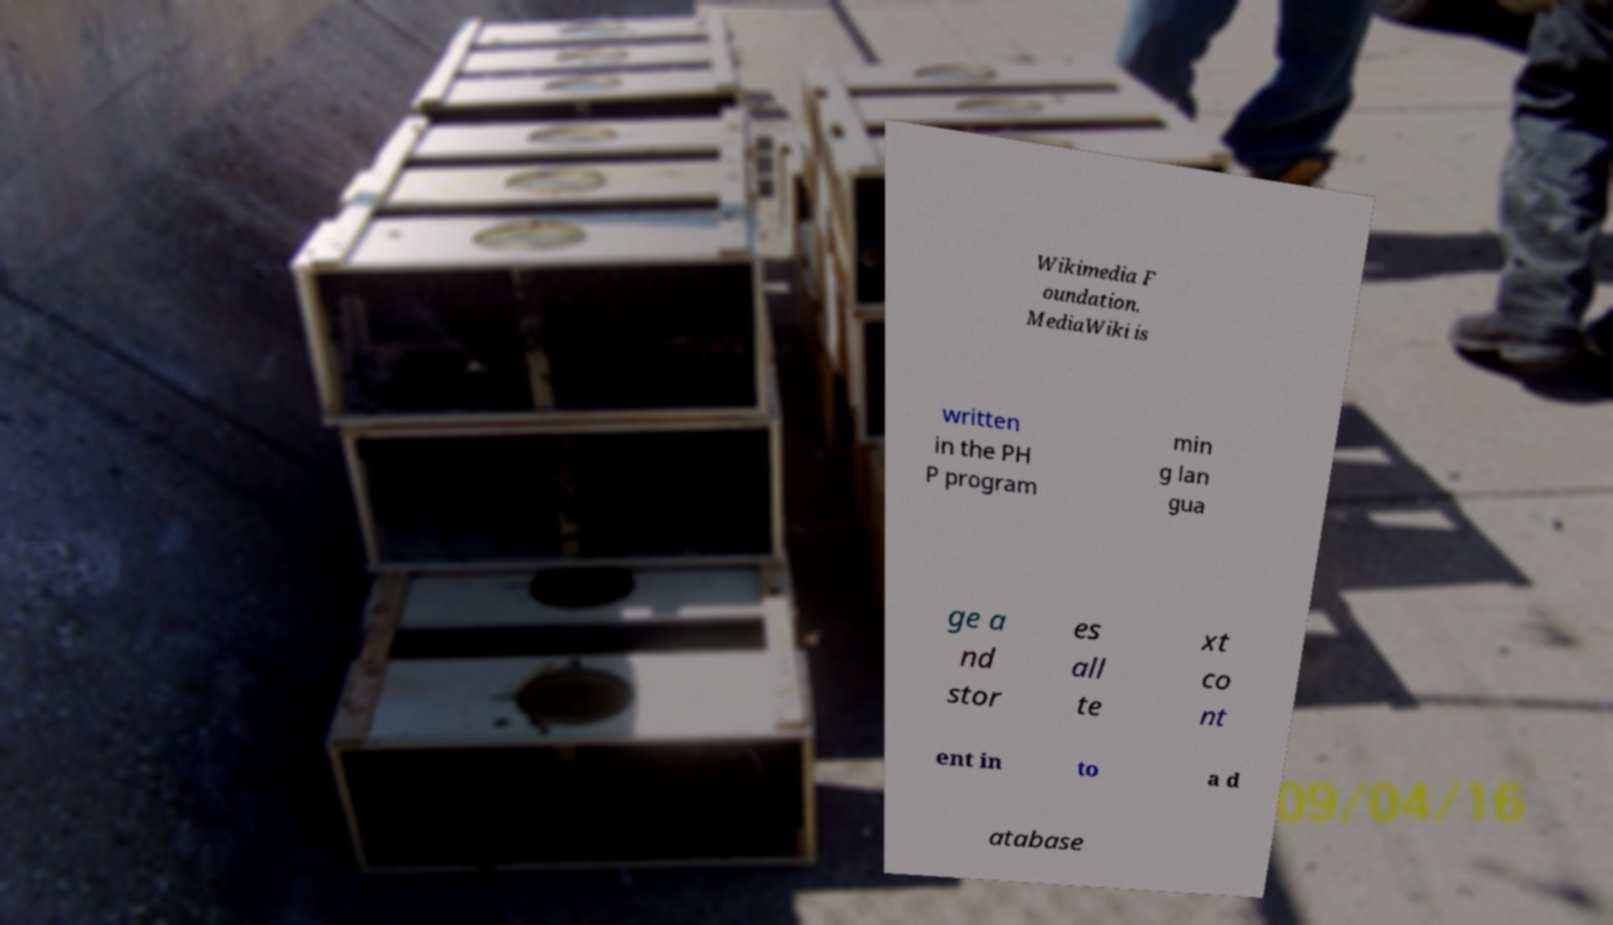Can you read and provide the text displayed in the image?This photo seems to have some interesting text. Can you extract and type it out for me? Wikimedia F oundation. MediaWiki is written in the PH P program min g lan gua ge a nd stor es all te xt co nt ent in to a d atabase 